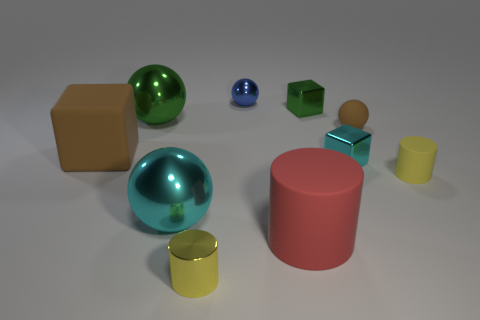There is another tiny cylinder that is made of the same material as the red cylinder; what color is it?
Provide a short and direct response. Yellow. Is the number of tiny metallic spheres on the right side of the red object less than the number of big brown things?
Make the answer very short. Yes. There is a red thing that is the same material as the tiny brown sphere; what is its shape?
Keep it short and to the point. Cylinder. What number of matte things are either large cylinders or cyan objects?
Keep it short and to the point. 1. Are there the same number of balls behind the brown ball and tiny green rubber balls?
Keep it short and to the point. No. There is a shiny ball in front of the green metal ball; does it have the same color as the matte sphere?
Your response must be concise. No. What material is the block that is both to the right of the blue shiny sphere and in front of the tiny green object?
Your answer should be compact. Metal. There is a block left of the yellow metal object; are there any big cyan things that are behind it?
Ensure brevity in your answer.  No. Is the material of the large red thing the same as the green cube?
Your answer should be compact. No. There is a small metallic thing that is in front of the green shiny sphere and to the right of the big rubber cylinder; what shape is it?
Ensure brevity in your answer.  Cube. 